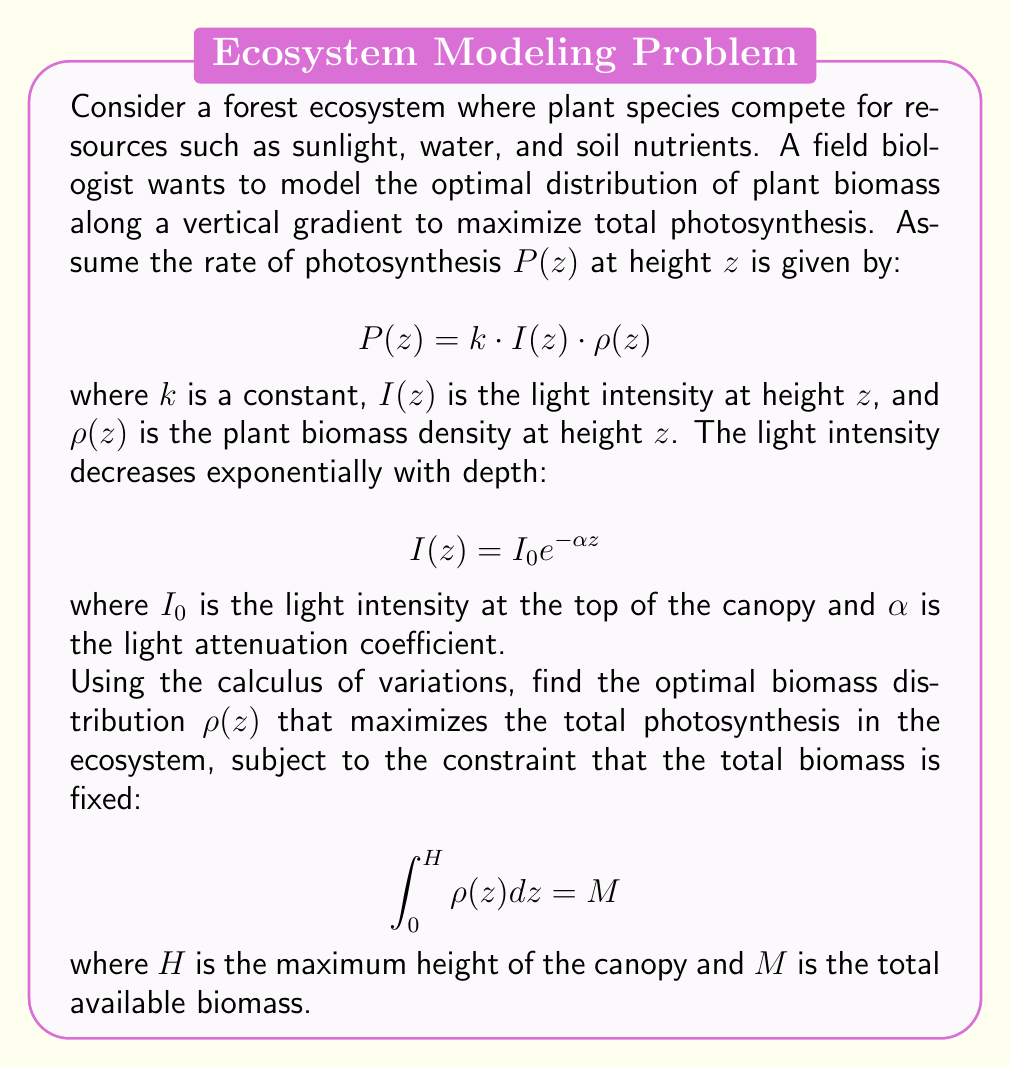Can you answer this question? To solve this problem, we'll use the Euler-Lagrange equation from the calculus of variations. Let's approach this step-by-step:

1) First, we need to formulate the functional to be maximized. The total photosynthesis is given by:

   $$J[\rho] = \int_0^H P(z) dz = k I_0 \int_0^H e^{-\alpha z} \rho(z) dz$$

2) We also have the constraint:

   $$\int_0^H \rho(z) dz = M$$

3) We can incorporate this constraint using a Lagrange multiplier $\lambda$. Our new functional becomes:

   $$J[\rho] = k I_0 \int_0^H e^{-\alpha z} \rho(z) dz - \lambda \left(\int_0^H \rho(z) dz - M\right)$$

4) The integrand of this functional is:

   $$F(z, \rho, \rho') = k I_0 e^{-\alpha z} \rho(z) - \lambda \rho(z)$$

   Note that $F$ doesn't depend on $\rho'(z)$.

5) The Euler-Lagrange equation for this problem is:

   $$\frac{\partial F}{\partial \rho} - \frac{d}{dz}\left(\frac{\partial F}{\partial \rho'}\right) = 0$$

6) Since $F$ doesn't depend on $\rho'$, this simplifies to:

   $$\frac{\partial F}{\partial \rho} = 0$$

7) Calculating this partial derivative:

   $$k I_0 e^{-\alpha z} - \lambda = 0$$

8) Solving for $\rho(z)$:

   $$\rho(z) = \begin{cases} 
      \infty & \text{if } k I_0 e^{-\alpha z} > \lambda \\
      0 & \text{if } k I_0 e^{-\alpha z} < \lambda \\
      \text{undetermined} & \text{if } k I_0 e^{-\alpha z} = \lambda
   \end{cases}$$

9) This result suggests that the optimal distribution is to concentrate all biomass at a single height $z^*$ where:

   $$k I_0 e^{-\alpha z^*} = \lambda$$

10) Solving for $z^*$:

    $$z^* = -\frac{1}{\alpha} \ln\left(\frac{\lambda}{k I_0}\right)$$

11) To satisfy the biomass constraint, we must have:

    $$\rho(z) = M \delta(z - z^*)$$

    where $\delta$ is the Dirac delta function.

This solution represents an idealized scenario where all biomass is concentrated at a single optimal height. In reality, physical and biological constraints would prevent such a distribution, but this model provides insight into the theoretical optimum.
Answer: The optimal biomass distribution that maximizes total photosynthesis in the ecosystem is:

$$\rho(z) = M \delta\left(z + \frac{1}{\alpha} \ln\left(\frac{\lambda}{k I_0}\right)\right)$$

where $\delta$ is the Dirac delta function, and $\lambda$ is determined by the specific values of $k$, $I_0$, and $\alpha$. This distribution concentrates all biomass at the height $z^* = -\frac{1}{\alpha} \ln\left(\frac{\lambda}{k I_0}\right)$. 